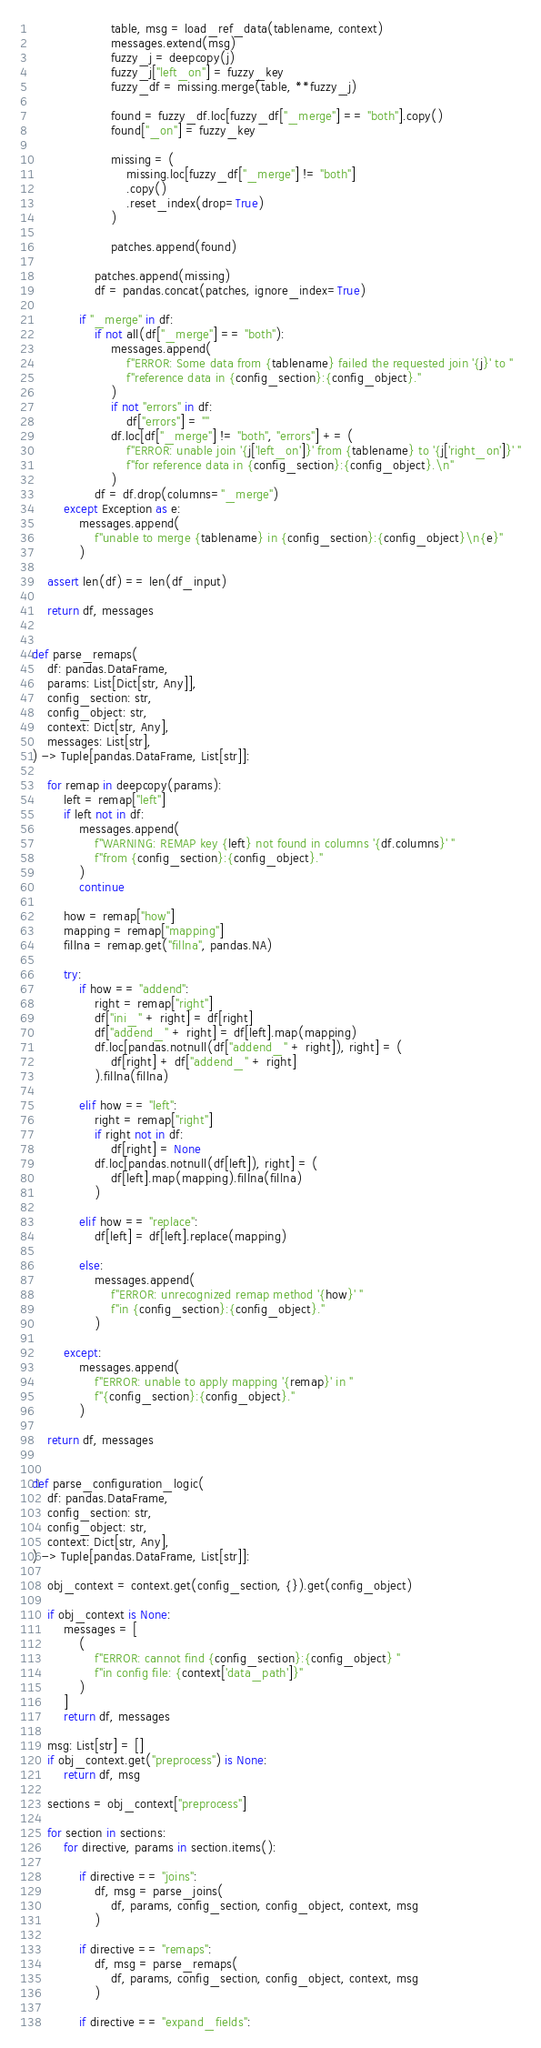Convert code to text. <code><loc_0><loc_0><loc_500><loc_500><_Python_>                    table, msg = load_ref_data(tablename, context)
                    messages.extend(msg)
                    fuzzy_j = deepcopy(j)
                    fuzzy_j["left_on"] = fuzzy_key
                    fuzzy_df = missing.merge(table, **fuzzy_j)

                    found = fuzzy_df.loc[fuzzy_df["_merge"] == "both"].copy()
                    found["_on"] = fuzzy_key

                    missing = (
                        missing.loc[fuzzy_df["_merge"] != "both"]
                        .copy()
                        .reset_index(drop=True)
                    )

                    patches.append(found)

                patches.append(missing)
                df = pandas.concat(patches, ignore_index=True)

            if "_merge" in df:
                if not all(df["_merge"] == "both"):
                    messages.append(
                        f"ERROR: Some data from {tablename} failed the requested join '{j}' to "
                        f"reference data in {config_section}:{config_object}."
                    )
                    if not "errors" in df:
                        df["errors"] = ""
                    df.loc[df["_merge"] != "both", "errors"] += (
                        f"ERROR: unable join '{j['left_on']}' from {tablename} to '{j['right_on']}' "
                        f"for reference data in {config_section}:{config_object}.\n"
                    )
                df = df.drop(columns="_merge")
        except Exception as e:
            messages.append(
                f"unable to merge {tablename} in {config_section}:{config_object}\n{e}"
            )

    assert len(df) == len(df_input)

    return df, messages


def parse_remaps(
    df: pandas.DataFrame,
    params: List[Dict[str, Any]],
    config_section: str,
    config_object: str,
    context: Dict[str, Any],
    messages: List[str],
) -> Tuple[pandas.DataFrame, List[str]]:

    for remap in deepcopy(params):
        left = remap["left"]
        if left not in df:
            messages.append(
                f"WARNING: REMAP key {left} not found in columns '{df.columns}' "
                f"from {config_section}:{config_object}."
            )
            continue

        how = remap["how"]
        mapping = remap["mapping"]
        fillna = remap.get("fillna", pandas.NA)

        try:
            if how == "addend":
                right = remap["right"]
                df["ini_" + right] = df[right]
                df["addend_" + right] = df[left].map(mapping)
                df.loc[pandas.notnull(df["addend_" + right]), right] = (
                    df[right] + df["addend_" + right]
                ).fillna(fillna)

            elif how == "left":
                right = remap["right"]
                if right not in df:
                    df[right] = None
                df.loc[pandas.notnull(df[left]), right] = (
                    df[left].map(mapping).fillna(fillna)
                )

            elif how == "replace":
                df[left] = df[left].replace(mapping)

            else:
                messages.append(
                    f"ERROR: unrecognized remap method '{how}' "
                    f"in {config_section}:{config_object}."
                )

        except:
            messages.append(
                f"ERROR: unable to apply mapping '{remap}' in "
                f"{config_section}:{config_object}."
            )

    return df, messages


def parse_configuration_logic(
    df: pandas.DataFrame,
    config_section: str,
    config_object: str,
    context: Dict[str, Any],
) -> Tuple[pandas.DataFrame, List[str]]:

    obj_context = context.get(config_section, {}).get(config_object)

    if obj_context is None:
        messages = [
            (
                f"ERROR: cannot find {config_section}:{config_object} "
                f"in config file: {context['data_path']}"
            )
        ]
        return df, messages

    msg: List[str] = []
    if obj_context.get("preprocess") is None:
        return df, msg

    sections = obj_context["preprocess"]

    for section in sections:
        for directive, params in section.items():

            if directive == "joins":
                df, msg = parse_joins(
                    df, params, config_section, config_object, context, msg
                )

            if directive == "remaps":
                df, msg = parse_remaps(
                    df, params, config_section, config_object, context, msg
                )

            if directive == "expand_fields":</code> 